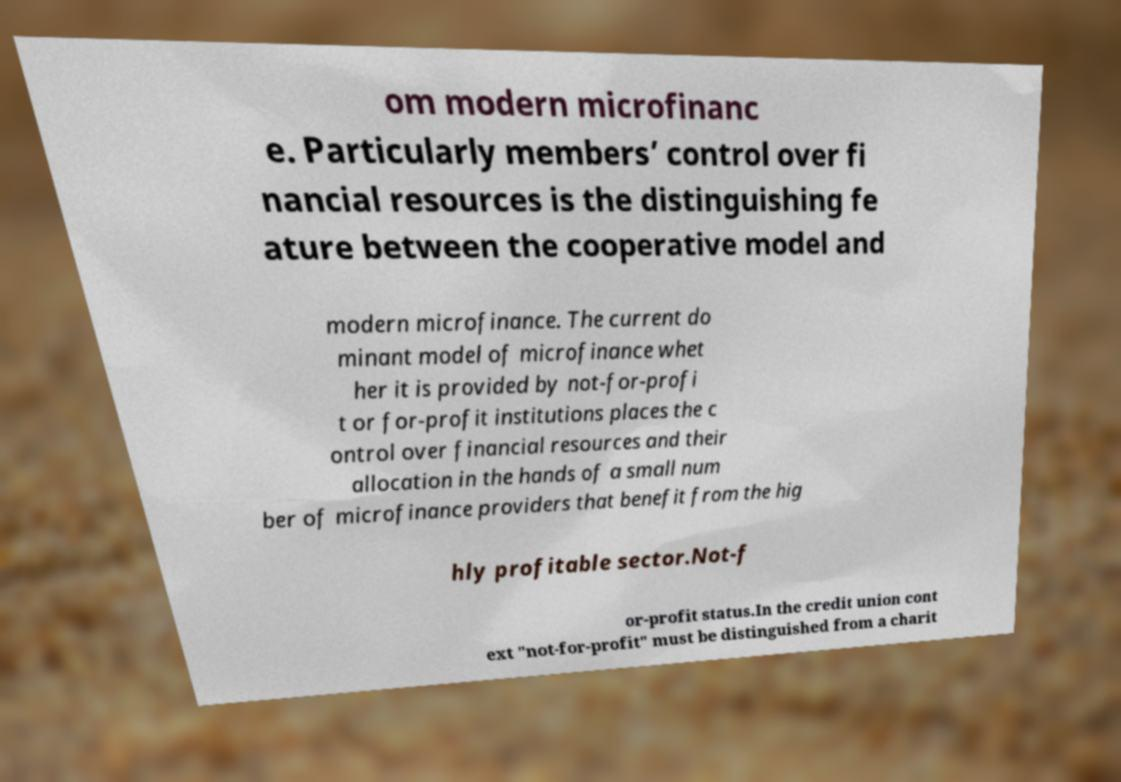I need the written content from this picture converted into text. Can you do that? om modern microfinanc e. Particularly members’ control over fi nancial resources is the distinguishing fe ature between the cooperative model and modern microfinance. The current do minant model of microfinance whet her it is provided by not-for-profi t or for-profit institutions places the c ontrol over financial resources and their allocation in the hands of a small num ber of microfinance providers that benefit from the hig hly profitable sector.Not-f or-profit status.In the credit union cont ext "not-for-profit" must be distinguished from a charit 